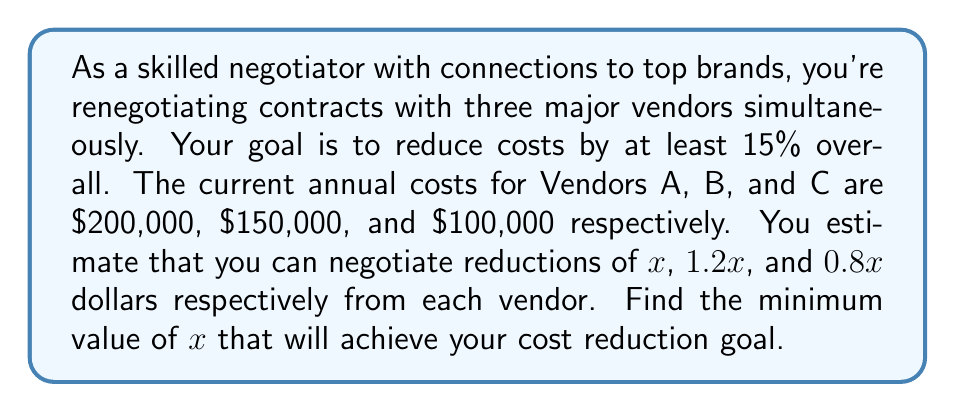Could you help me with this problem? Let's approach this step-by-step:

1) First, let's calculate the total current cost:
   $200,000 + $150,000 + $100,000 = $450,000

2) We want to reduce this by at least 15%:
   $450,000 * 0.15 = $67,500

3) So, the new total cost should be at most:
   $450,000 - $67,500 = $382,500

4) Now, let's set up an inequality. The new costs after negotiation should be less than or equal to $382,500:
   $(200,000 - x) + (150,000 - 1.2x) + (100,000 - 0.8x) \leq 382,500$

5) Simplify the left side of the inequality:
   $450,000 - 3x \leq 382,500$

6) Subtract 450,000 from both sides:
   $-3x \leq -67,500$

7) Divide both sides by -3 (and flip the inequality sign):
   $x \geq 22,500$

Therefore, $x$ must be at least $22,500 to achieve the desired cost reduction.
Answer: The minimum value of $x$ is $22,500. 